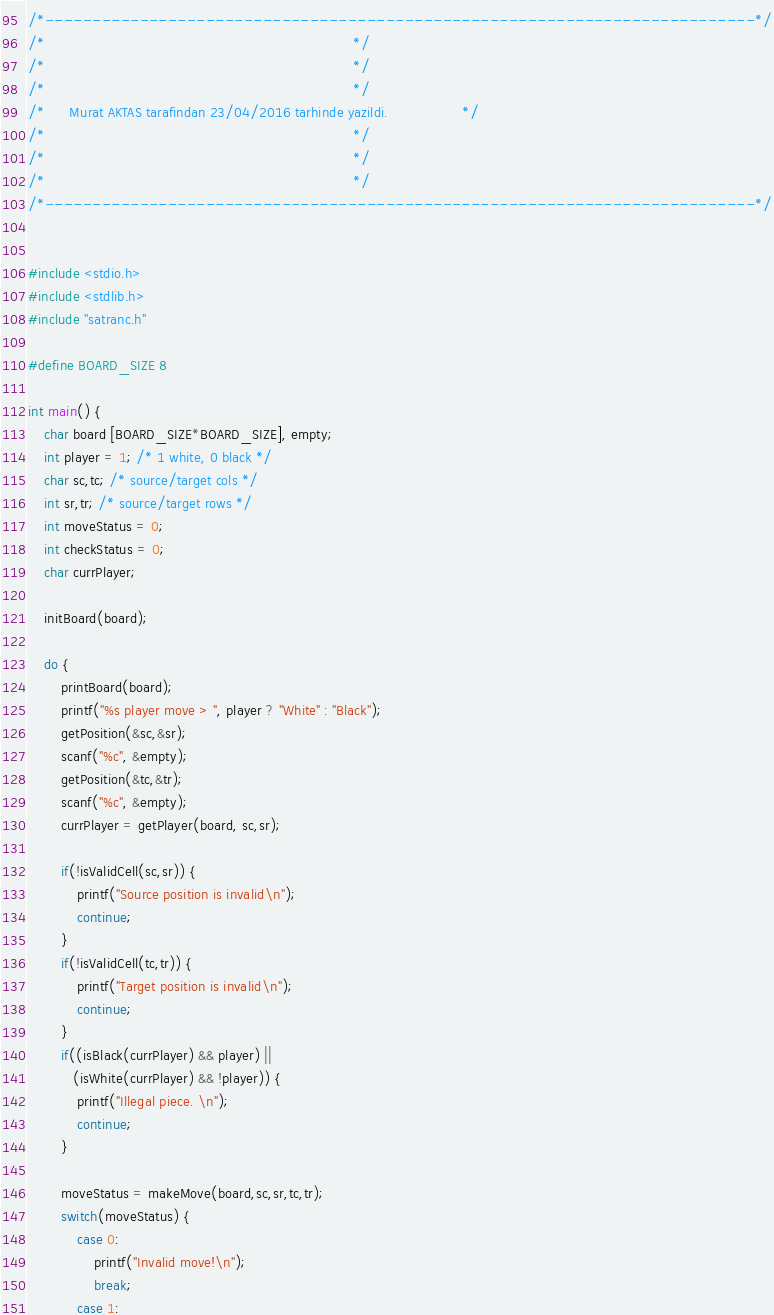Convert code to text. <code><loc_0><loc_0><loc_500><loc_500><_C_>/*---------------------------------------------------------------------------*/
/*                                                                           */
/*      						                                             */
/*                                                                           */
/*      Murat AKTAS tarafindan 23/04/2016 tarhinde yazildi.                  */
/*                                                                           */
/*                                                                           */
/*                                                                           */
/*---------------------------------------------------------------------------*/


#include <stdio.h>
#include <stdlib.h>
#include "satranc.h"

#define BOARD_SIZE 8

int main() {
    char board [BOARD_SIZE*BOARD_SIZE], empty;
    int player = 1; /* 1 white, 0 black */
    char sc,tc; /* source/target cols */
    int sr,tr; /* source/target rows */
    int moveStatus = 0;
    int checkStatus = 0;
    char currPlayer;

    initBoard(board);

    do {
        printBoard(board);
        printf("%s player move > ", player ? "White" : "Black");
        getPosition(&sc,&sr);
        scanf("%c", &empty);
        getPosition(&tc,&tr);
        scanf("%c", &empty);
        currPlayer = getPlayer(board, sc,sr);

        if(!isValidCell(sc,sr)) {
            printf("Source position is invalid\n");
            continue;
        }
        if(!isValidCell(tc,tr)) {
            printf("Target position is invalid\n");
            continue;
        }
        if((isBlack(currPlayer) && player) ||
           (isWhite(currPlayer) && !player)) {
            printf("Illegal piece. \n");
            continue;
        }

        moveStatus = makeMove(board,sc,sr,tc,tr);
        switch(moveStatus) {
            case 0:
                printf("Invalid move!\n");
                break;
            case 1:</code> 